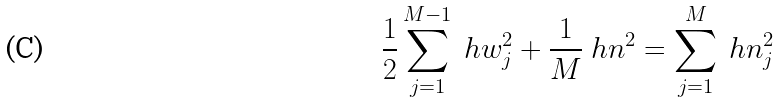Convert formula to latex. <formula><loc_0><loc_0><loc_500><loc_500>\frac { 1 } { 2 } \sum _ { j = 1 } ^ { M - 1 } \ h w _ { j } ^ { 2 } + \frac { 1 } { M } \ h n ^ { 2 } = \sum _ { j = 1 } ^ { M } \ h n _ { j } ^ { 2 }</formula> 